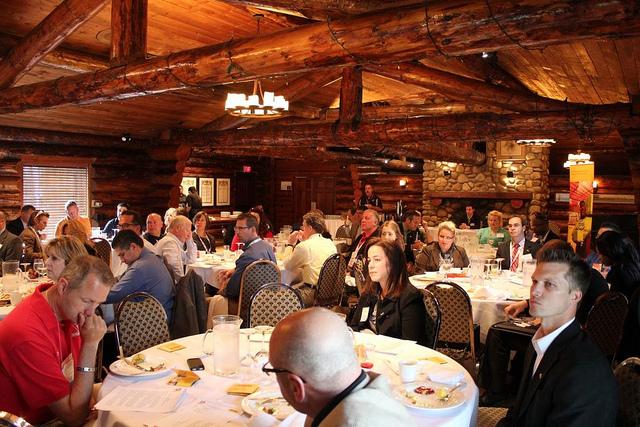What is the ceiling made out of?
Answer briefly. Wood. Are these people ready to eat?
Keep it brief. Yes. Is the restaurant crowded?
Give a very brief answer. Yes. 